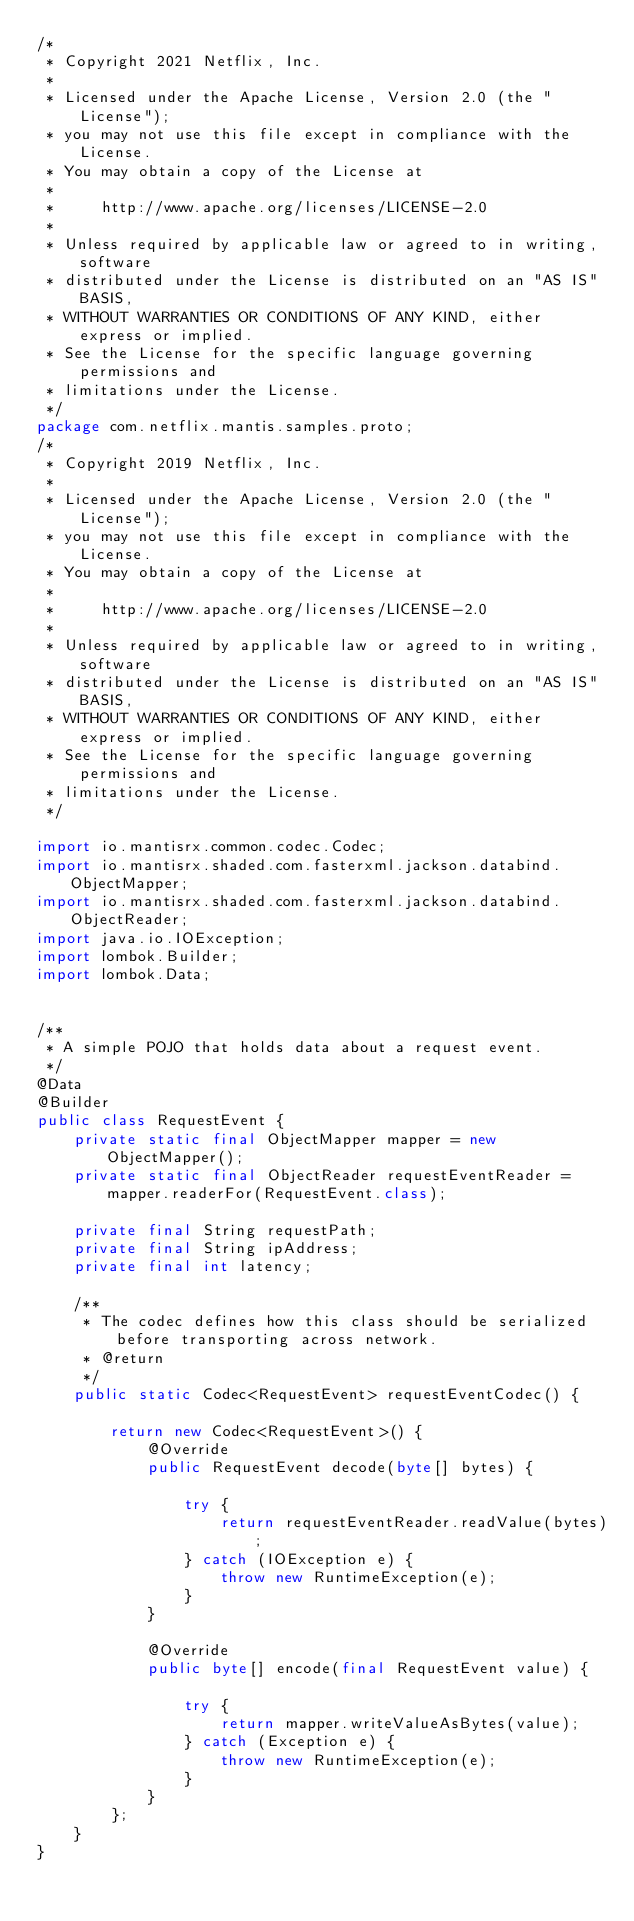Convert code to text. <code><loc_0><loc_0><loc_500><loc_500><_Java_>/*
 * Copyright 2021 Netflix, Inc.
 *
 * Licensed under the Apache License, Version 2.0 (the "License");
 * you may not use this file except in compliance with the License.
 * You may obtain a copy of the License at
 *
 *     http://www.apache.org/licenses/LICENSE-2.0
 *
 * Unless required by applicable law or agreed to in writing, software
 * distributed under the License is distributed on an "AS IS" BASIS,
 * WITHOUT WARRANTIES OR CONDITIONS OF ANY KIND, either express or implied.
 * See the License for the specific language governing permissions and
 * limitations under the License.
 */
package com.netflix.mantis.samples.proto;
/*
 * Copyright 2019 Netflix, Inc.
 *
 * Licensed under the Apache License, Version 2.0 (the "License");
 * you may not use this file except in compliance with the License.
 * You may obtain a copy of the License at
 *
 *     http://www.apache.org/licenses/LICENSE-2.0
 *
 * Unless required by applicable law or agreed to in writing, software
 * distributed under the License is distributed on an "AS IS" BASIS,
 * WITHOUT WARRANTIES OR CONDITIONS OF ANY KIND, either express or implied.
 * See the License for the specific language governing permissions and
 * limitations under the License.
 */

import io.mantisrx.common.codec.Codec;
import io.mantisrx.shaded.com.fasterxml.jackson.databind.ObjectMapper;
import io.mantisrx.shaded.com.fasterxml.jackson.databind.ObjectReader;
import java.io.IOException;
import lombok.Builder;
import lombok.Data;


/**
 * A simple POJO that holds data about a request event.
 */
@Data
@Builder
public class RequestEvent {
    private static final ObjectMapper mapper = new ObjectMapper();
    private static final ObjectReader requestEventReader = mapper.readerFor(RequestEvent.class);

    private final String requestPath;
    private final String ipAddress;
    private final int latency;

    /**
     * The codec defines how this class should be serialized before transporting across network.
     * @return
     */
    public static Codec<RequestEvent> requestEventCodec() {

        return new Codec<RequestEvent>() {
            @Override
            public RequestEvent decode(byte[] bytes) {

                try {
                    return requestEventReader.readValue(bytes);
                } catch (IOException e) {
                    throw new RuntimeException(e);
                }
            }

            @Override
            public byte[] encode(final RequestEvent value) {

                try {
                    return mapper.writeValueAsBytes(value);
                } catch (Exception e) {
                    throw new RuntimeException(e);
                }
            }
        };
    }
}
</code> 